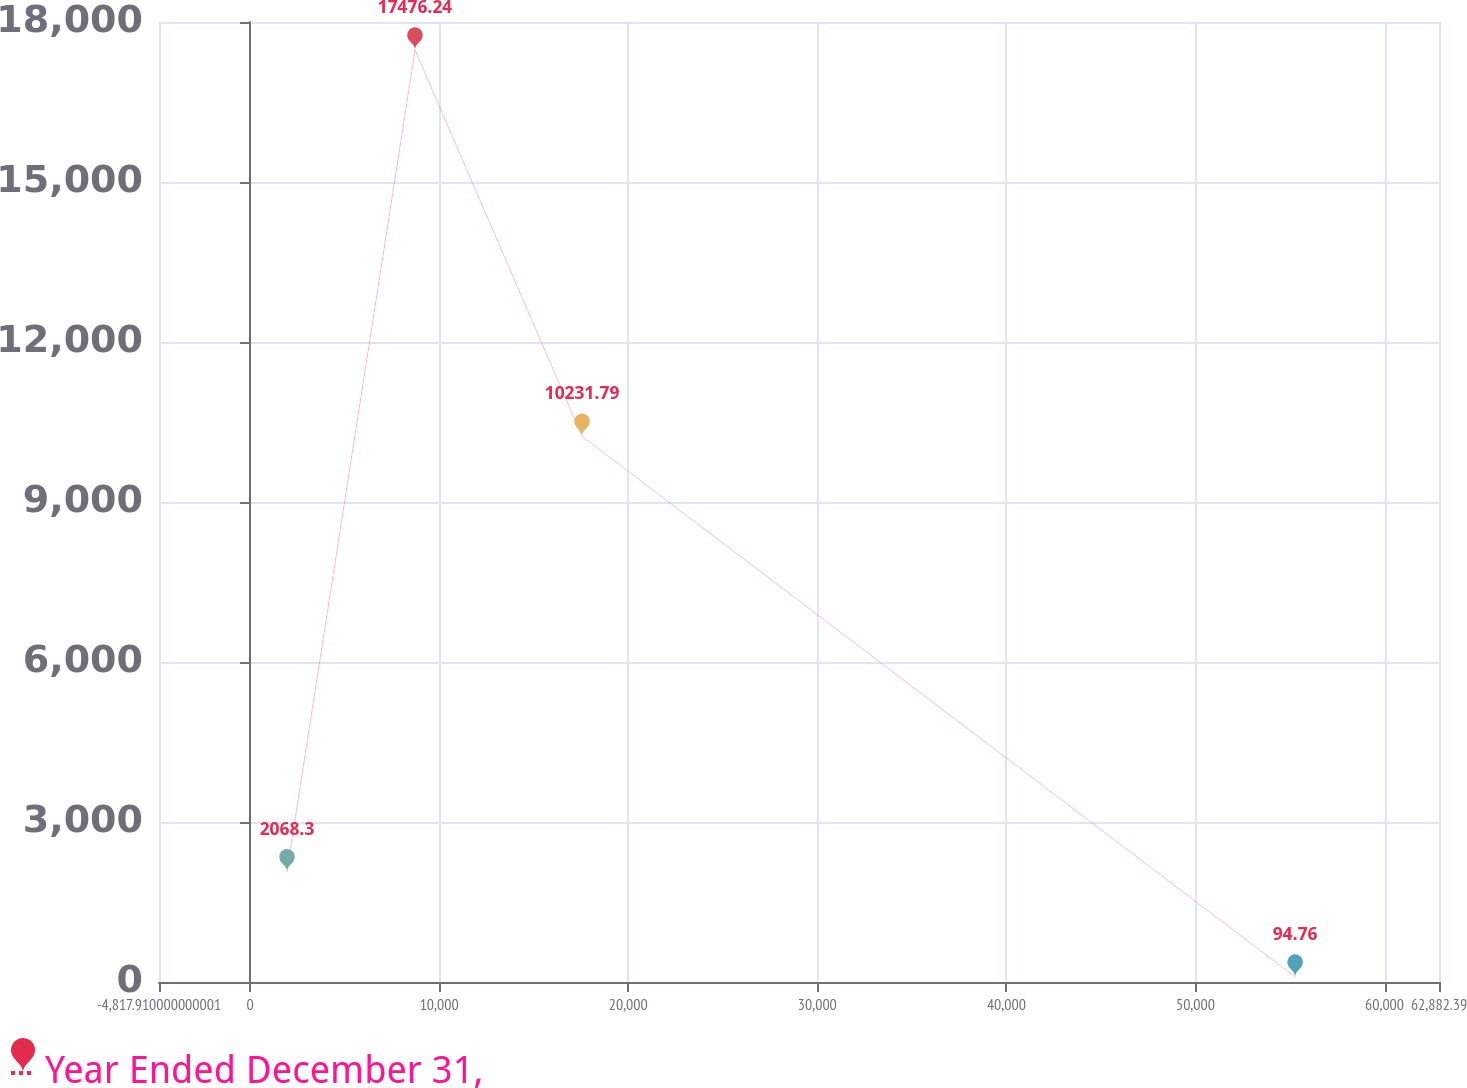Convert chart. <chart><loc_0><loc_0><loc_500><loc_500><line_chart><ecel><fcel>Year Ended December 31,<nl><fcel>1952.12<fcel>2068.3<nl><fcel>8722.15<fcel>17476.2<nl><fcel>17558<fcel>10231.8<nl><fcel>55273.1<fcel>94.76<nl><fcel>69652.4<fcel>6740.99<nl></chart> 